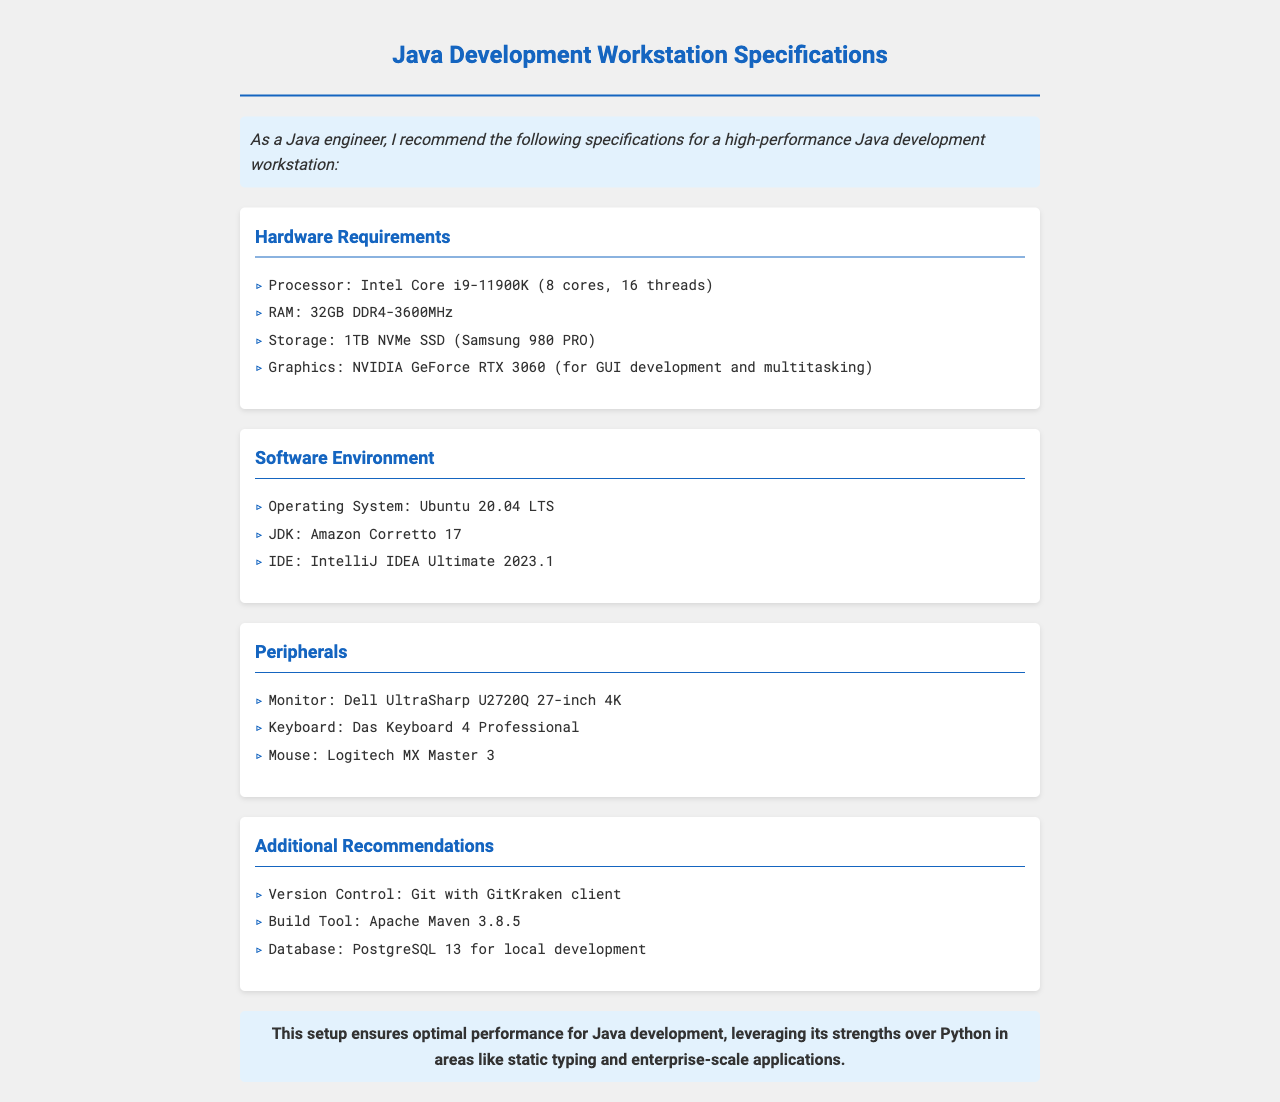What is the processor model recommended? The document lists the processor model as Intel Core i9-11900K as part of the hardware requirements.
Answer: Intel Core i9-11900K How much RAM is specified for the workstation? The specified amount of RAM for the workstation is mentioned under hardware requirements.
Answer: 32GB DDR4-3600MHz What operating system is recommended? The document indicates the recommended operating system for the software environment.
Answer: Ubuntu 20.04 LTS Which IDE is suggested for Java development? The IDE recommended for programming is listed under the software environment section.
Answer: IntelliJ IDEA Ultimate 2023.1 What is the monitor model suggested? The document suggests a specific model for the monitor in the peripherals section.
Answer: Dell UltraSharp U2720Q 27-inch 4K What additional tool is recommended for version control? A specific version control tool is suggested in the additional recommendations section.
Answer: Git with GitKraken client How many cores does the recommended processor have? The document specifies the number of cores in the processor model recommended, requiring a simple count.
Answer: 8 cores Which graphics card is recommended? The recommended graphics card is mentioned in the hardware requirements for the workstation.
Answer: NVIDIA GeForce RTX 3060 What is the conclusion highlighted in the document? The conclusion summarizes the strengths of the suggested setup over alternatives, specifically in Java development.
Answer: This setup ensures optimal performance for Java development, leveraging its strengths over Python in areas like static typing and enterprise-scale applications 